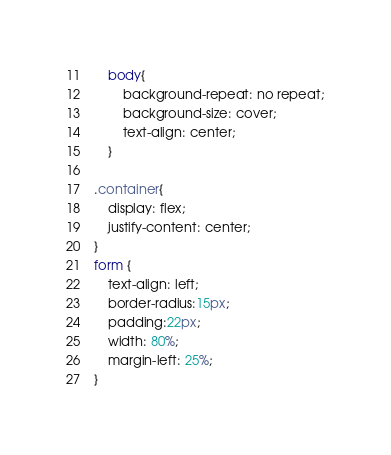<code> <loc_0><loc_0><loc_500><loc_500><_CSS_>
    body{
        background-repeat: no repeat;
        background-size: cover;
        text-align: center;
    }

.container{
    display: flex;
    justify-content: center;
}
form {
    text-align: left;
    border-radius:15px;
    padding:22px;
    width: 80%;
    margin-left: 25%;
}
</code> 